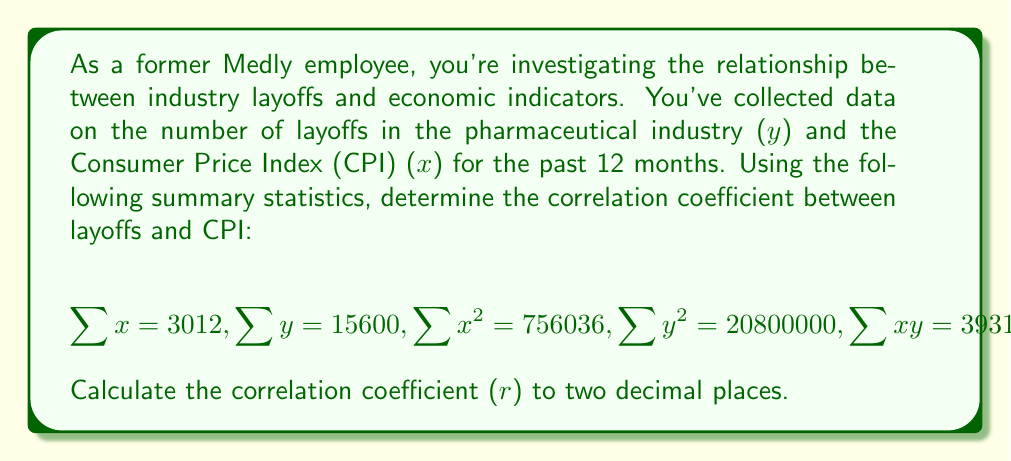Help me with this question. To calculate the correlation coefficient (r), we'll use the formula:

$$r = \frac{n\sum xy - \sum x \sum y}{\sqrt{[n\sum x^2 - (\sum x)^2][n\sum y^2 - (\sum y)^2]}}$$

Let's break this down step by step:

1. Calculate $n\sum xy$:
   $12 * 3931200 = 47174400$

2. Calculate $\sum x \sum y$:
   $3012 * 15600 = 46987200$

3. Calculate the numerator:
   $47174400 - 46987200 = 187200$

4. Calculate $n\sum x^2$:
   $12 * 756036 = 9072432$

5. Calculate $(\sum x)^2$:
   $3012^2 = 9072144$

6. Calculate $n\sum y^2$:
   $12 * 20800000 = 249600000$

7. Calculate $(\sum y)^2$:
   $15600^2 = 243360000$

8. Calculate the denominator:
   $\sqrt{[9072432 - 9072144][249600000 - 243360000]}$
   $= \sqrt{288 * 6240000}$
   $= \sqrt{1797120000}$
   $= 42391.89$

9. Finally, calculate r:
   $r = \frac{187200}{42391.89} = 4.4159$

10. Round to two decimal places:
    $r = 4.42$
Answer: The correlation coefficient (r) between industry layoffs and CPI is 4.42. 